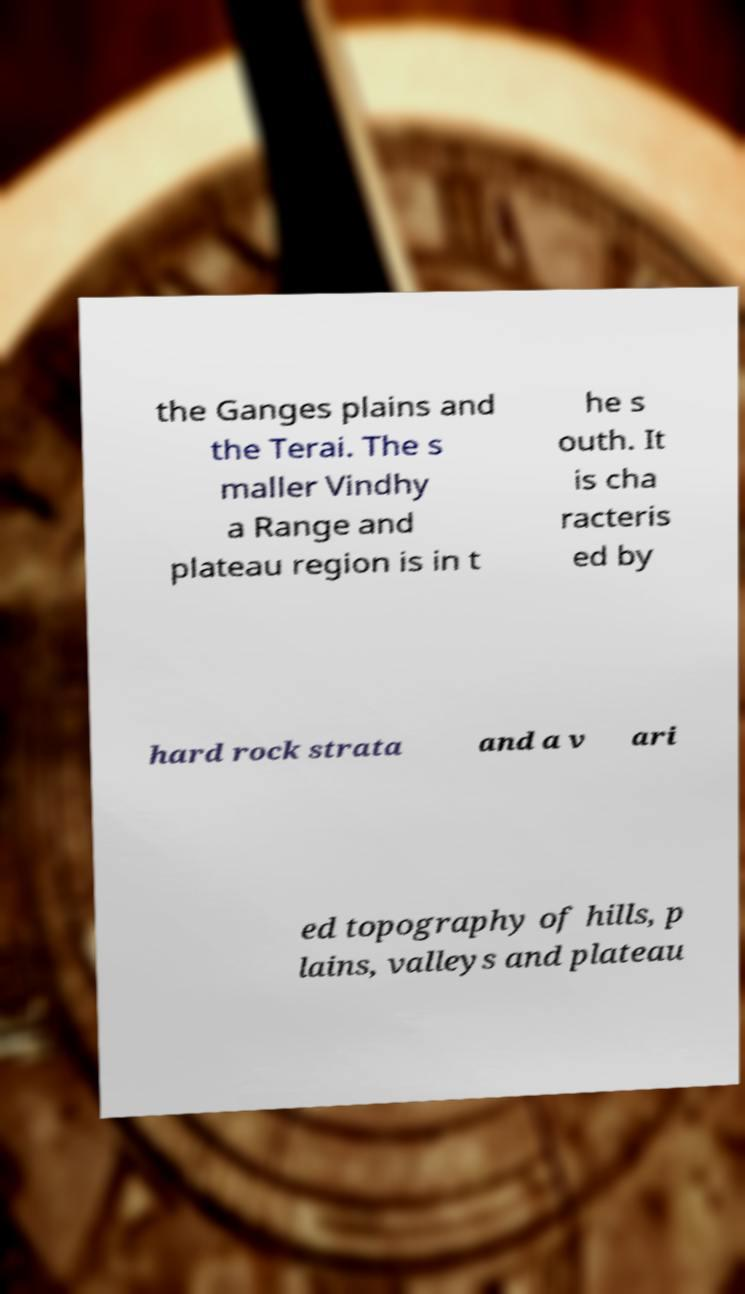Could you extract and type out the text from this image? the Ganges plains and the Terai. The s maller Vindhy a Range and plateau region is in t he s outh. It is cha racteris ed by hard rock strata and a v ari ed topography of hills, p lains, valleys and plateau 